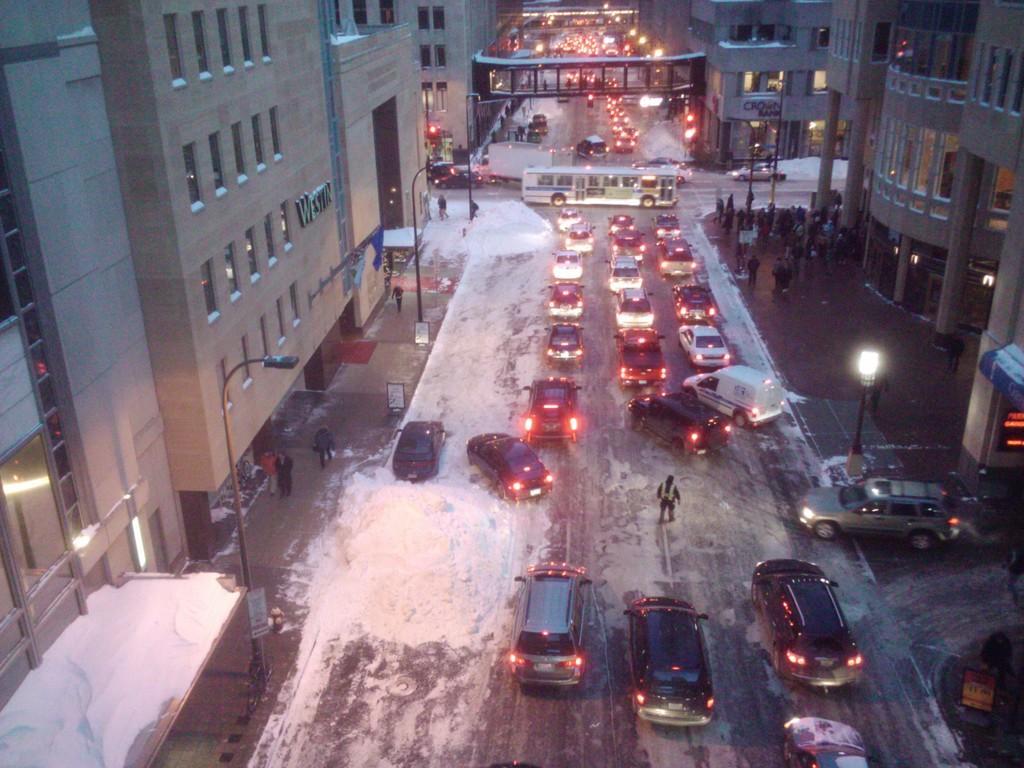Could you give a brief overview of what you see in this image? In this picture we can see some vehicles, on the left side and right side there are buildings, we can see foot over bridge in the middle, there are some pole, lights and some people in the middle, we can see windows of this building. 